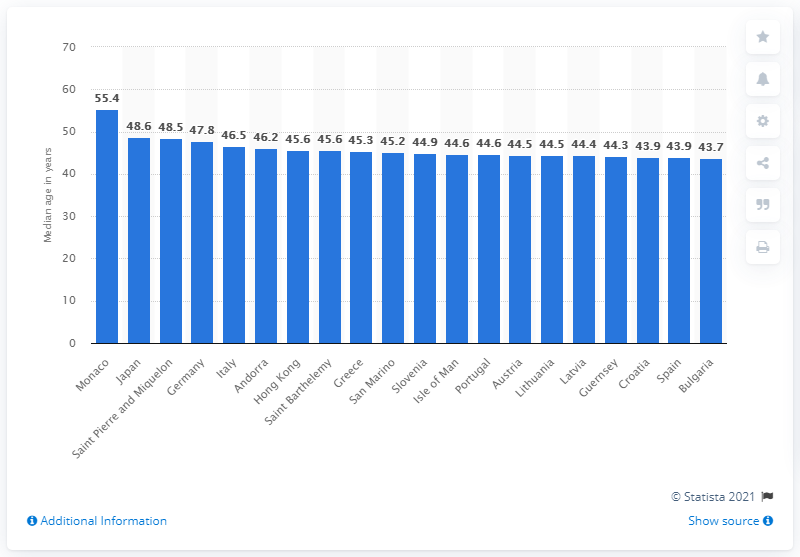Give some essential details in this illustration. According to recent data, the country with the highest median age in the world is Monaco. 